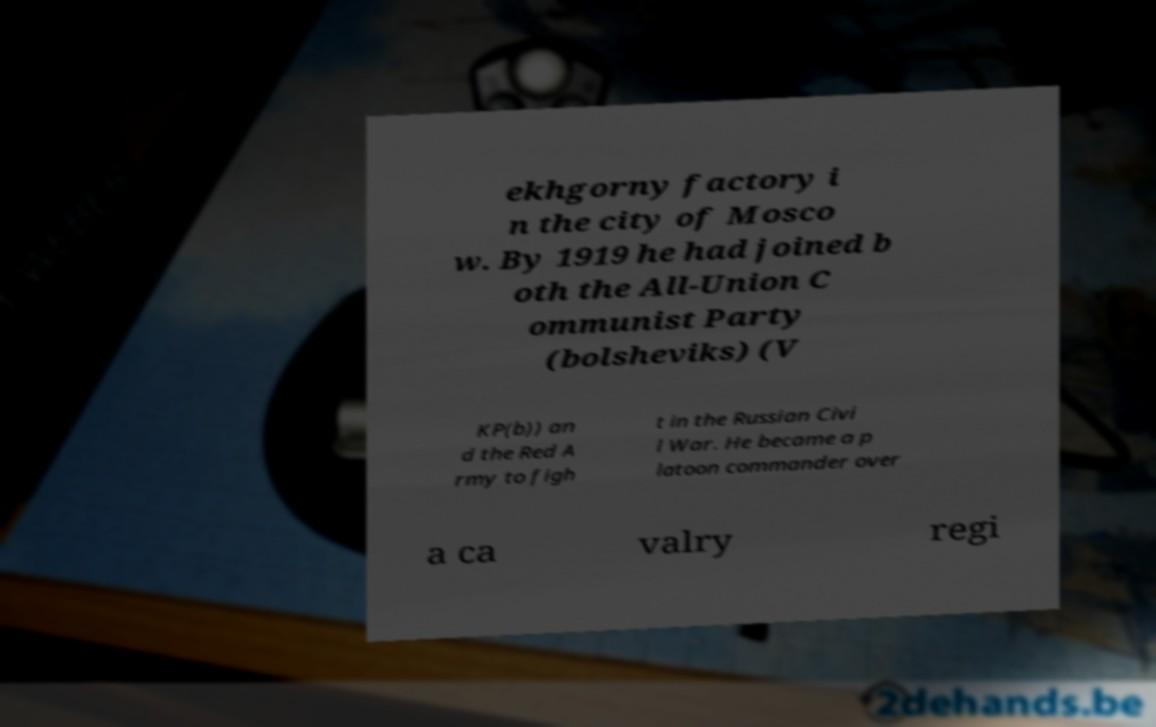Could you assist in decoding the text presented in this image and type it out clearly? ekhgorny factory i n the city of Mosco w. By 1919 he had joined b oth the All-Union C ommunist Party (bolsheviks) (V KP(b)) an d the Red A rmy to figh t in the Russian Civi l War. He became a p latoon commander over a ca valry regi 